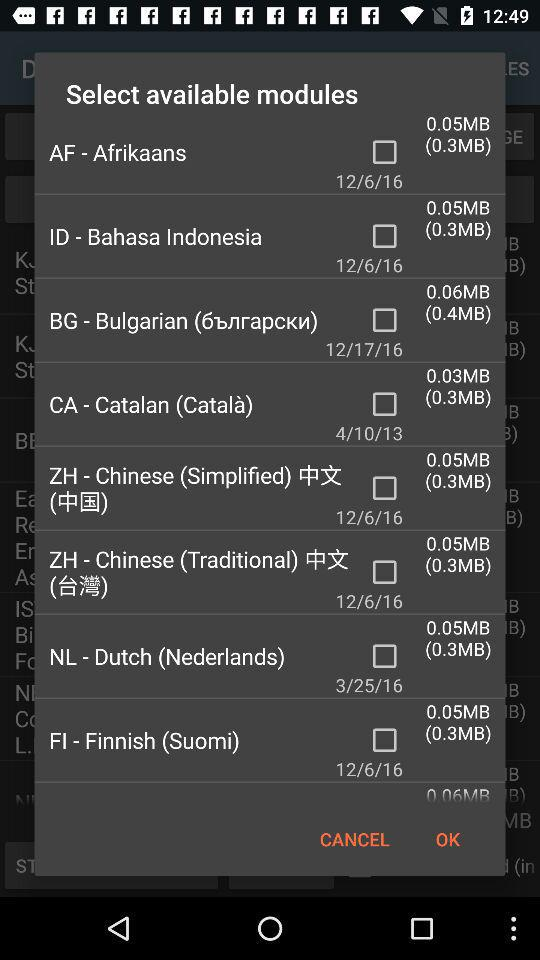What is the date mentioned for "NL - Dutch (Nederlends)" The date mentioned for "NL - Dutch (Nederlends)" is March 25, 2016. 